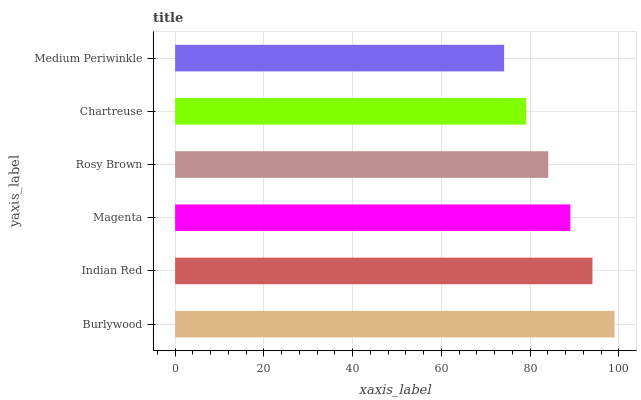Is Medium Periwinkle the minimum?
Answer yes or no. Yes. Is Burlywood the maximum?
Answer yes or no. Yes. Is Indian Red the minimum?
Answer yes or no. No. Is Indian Red the maximum?
Answer yes or no. No. Is Burlywood greater than Indian Red?
Answer yes or no. Yes. Is Indian Red less than Burlywood?
Answer yes or no. Yes. Is Indian Red greater than Burlywood?
Answer yes or no. No. Is Burlywood less than Indian Red?
Answer yes or no. No. Is Magenta the high median?
Answer yes or no. Yes. Is Rosy Brown the low median?
Answer yes or no. Yes. Is Chartreuse the high median?
Answer yes or no. No. Is Magenta the low median?
Answer yes or no. No. 